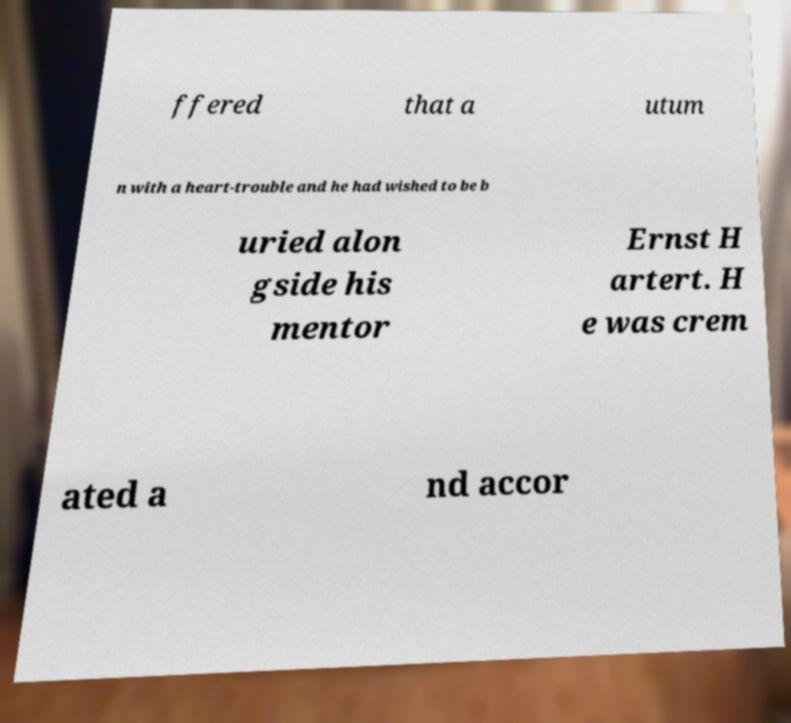Could you assist in decoding the text presented in this image and type it out clearly? ffered that a utum n with a heart-trouble and he had wished to be b uried alon gside his mentor Ernst H artert. H e was crem ated a nd accor 